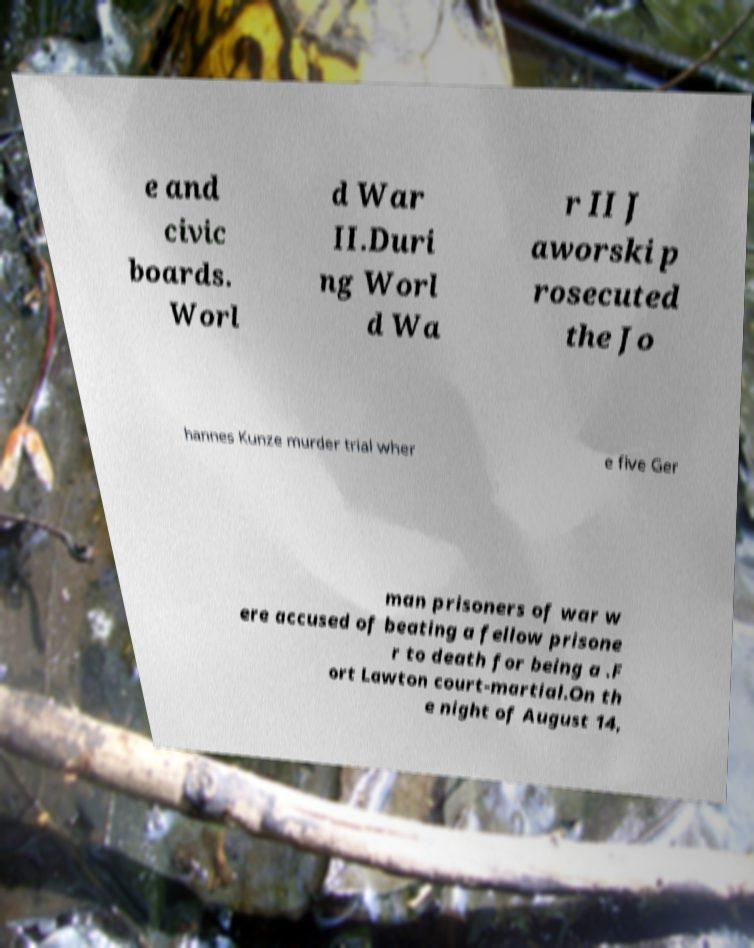Could you extract and type out the text from this image? e and civic boards. Worl d War II.Duri ng Worl d Wa r II J aworski p rosecuted the Jo hannes Kunze murder trial wher e five Ger man prisoners of war w ere accused of beating a fellow prisone r to death for being a .F ort Lawton court-martial.On th e night of August 14, 